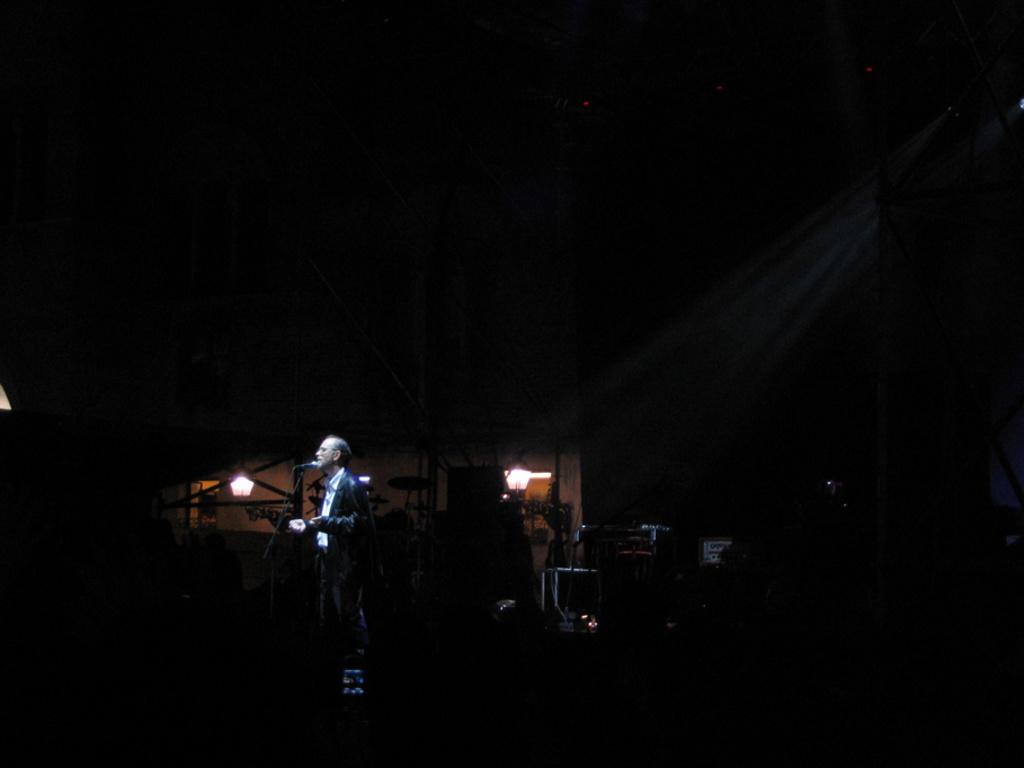What is the person in the image wearing? The person in the image is wearing a suit. What object is present that is commonly used for amplifying sound? There is a microphone (mic) in the image. What type of objects can be seen that are typically used for creating music? There are musical instruments in the image. What can be seen in the background of the image that provides illumination? There are lights visible in the background of the image. What type of sand can be seen in the image? There is no sand present in the image. What kind of vessel is being used to support the musical instruments in the image? There is no vessel or support structure for the musical instruments in the image; they are simply placed on the ground or a surface. 